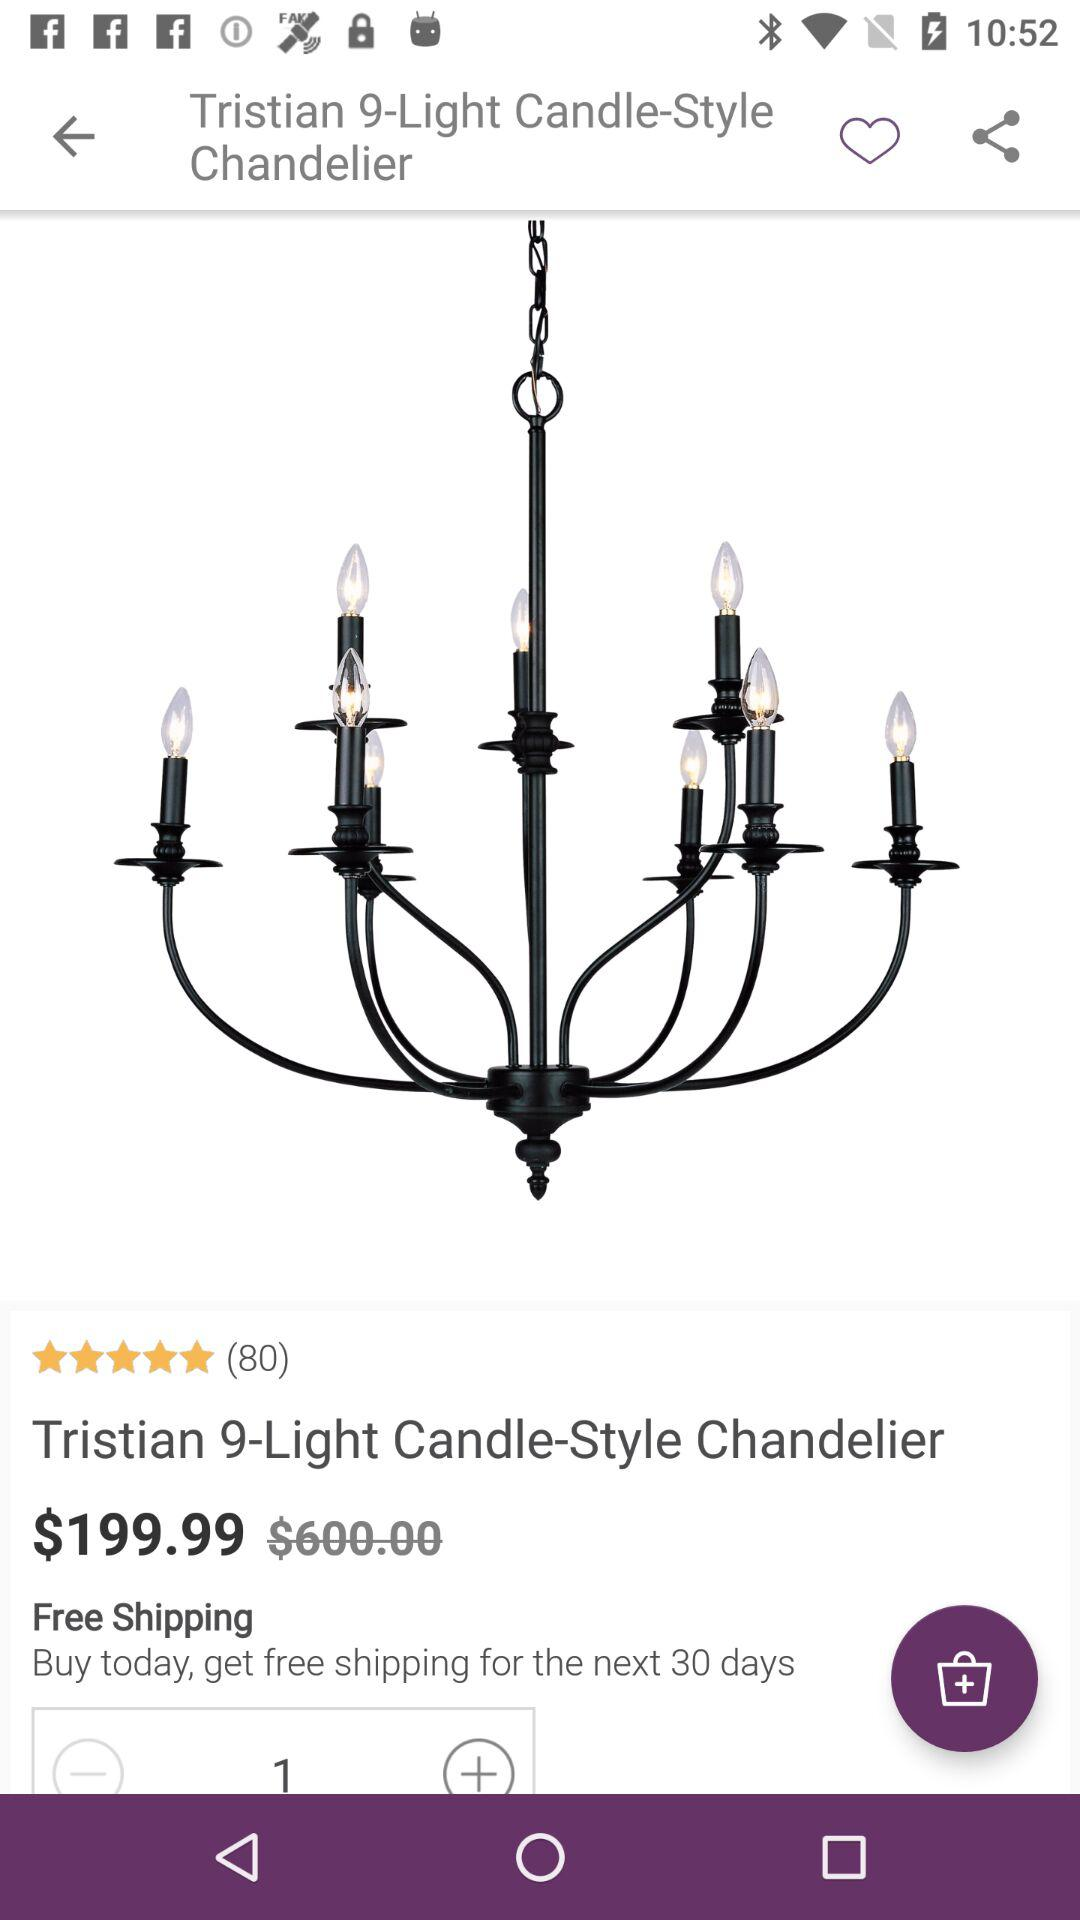How many people have rated "Tristian 9-Light Candle-Style Chandelier"? There are 80 people who have rated "Tristian 9-Light Candle-Style Chandelier". 